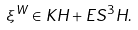<formula> <loc_0><loc_0><loc_500><loc_500>\xi ^ { W } \in K H + E S ^ { 3 } H .</formula> 